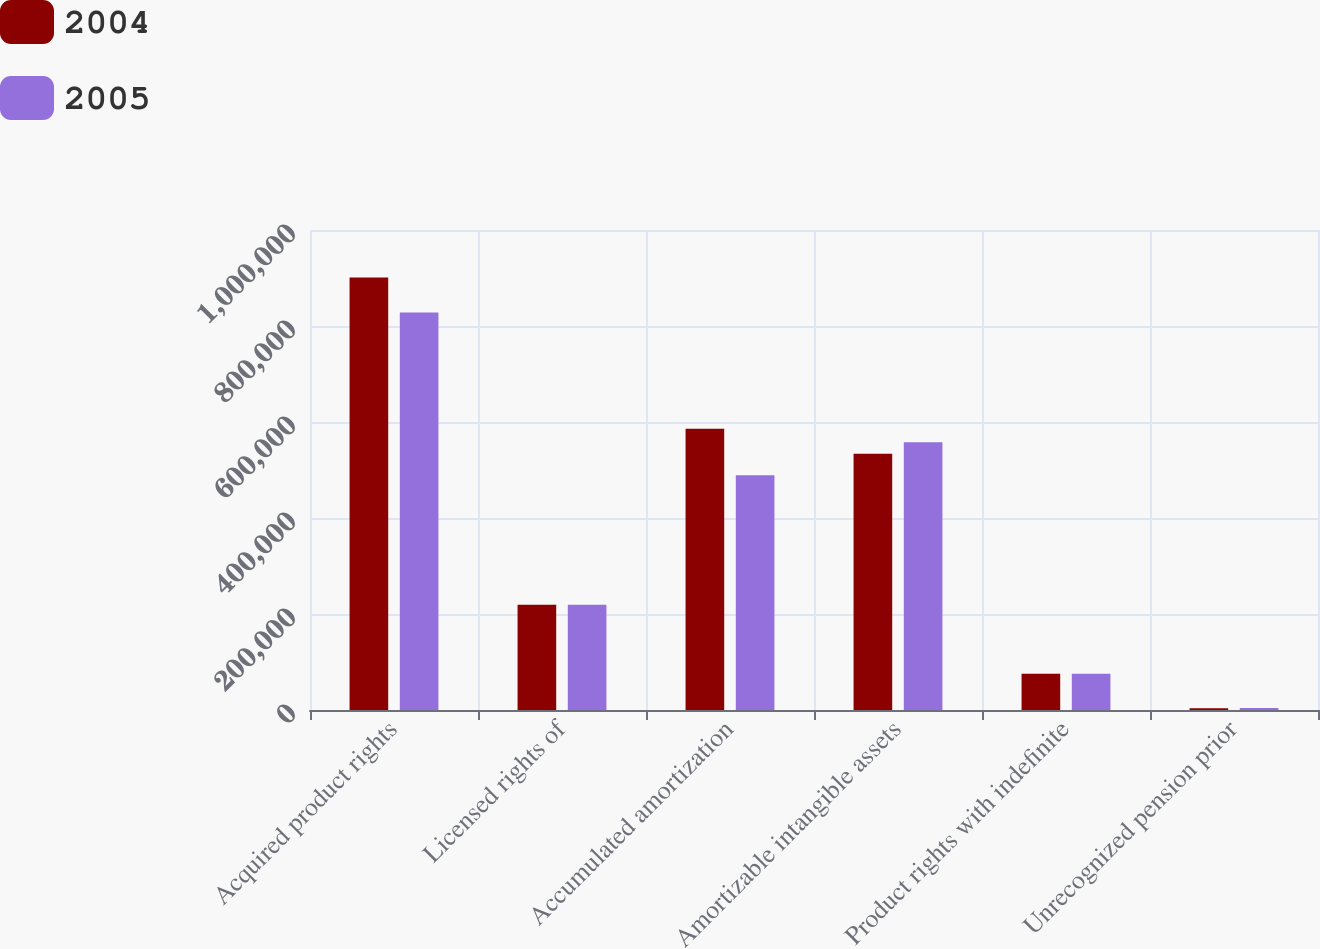Convert chart to OTSL. <chart><loc_0><loc_0><loc_500><loc_500><stacked_bar_chart><ecel><fcel>Acquired product rights<fcel>Licensed rights of<fcel>Accumulated amortization<fcel>Amortizable intangible assets<fcel>Product rights with indefinite<fcel>Unrecognized pension prior<nl><fcel>2004<fcel>900891<fcel>219071<fcel>586022<fcel>533940<fcel>75738<fcel>3755<nl><fcel>2005<fcel>828186<fcel>219071<fcel>489238<fcel>558019<fcel>75738<fcel>4172<nl></chart> 